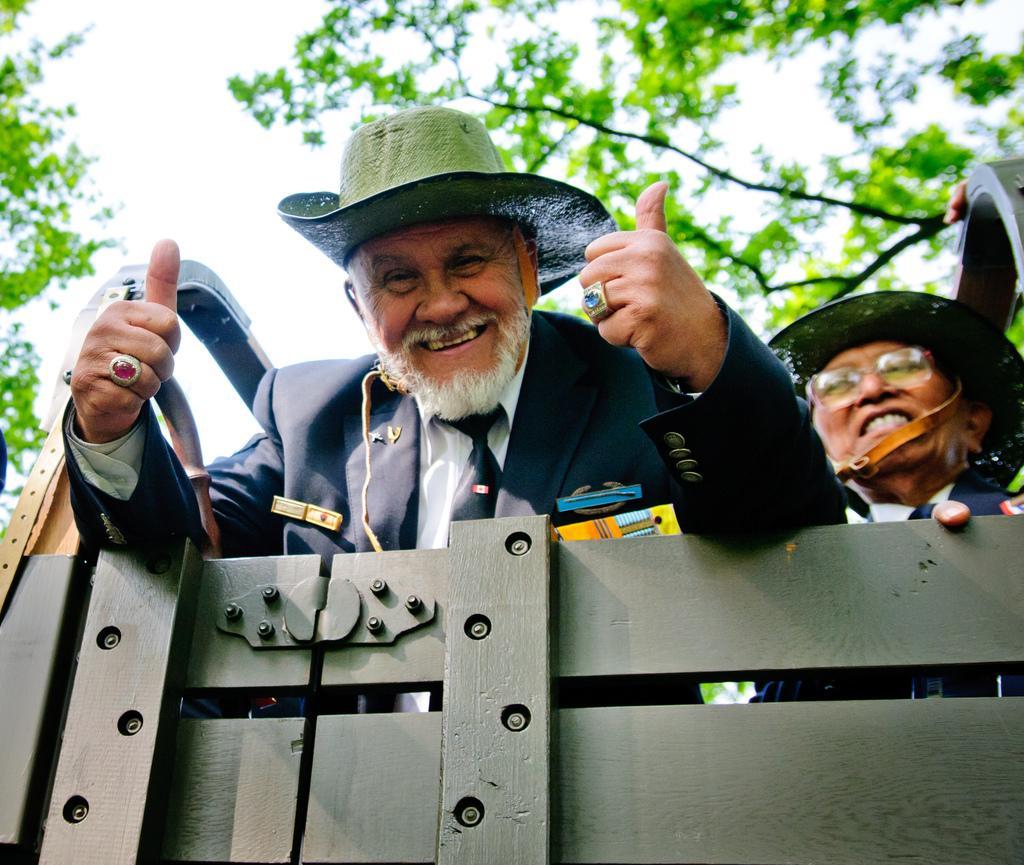In one or two sentences, can you explain what this image depicts? This image is taken outdoors. At the top of the image there is the sky. In the background there are a few trees with leaves, stems and branches. At the bottom of the image there is a cart. In the middle of the image there are two old men in the cart and they are with smiling faces. 